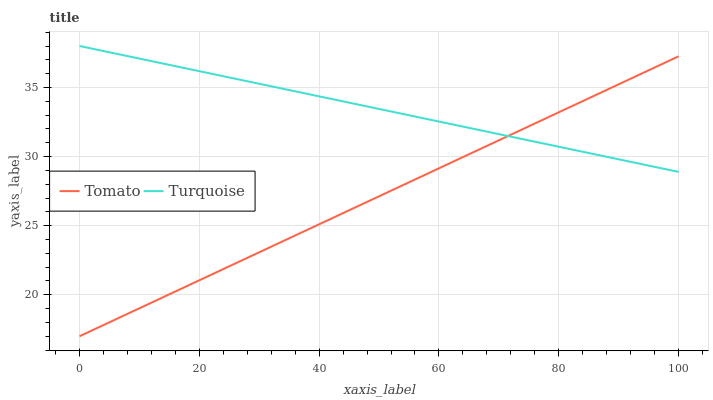Does Tomato have the minimum area under the curve?
Answer yes or no. Yes. Does Turquoise have the maximum area under the curve?
Answer yes or no. Yes. Does Turquoise have the minimum area under the curve?
Answer yes or no. No. Is Tomato the smoothest?
Answer yes or no. Yes. Is Turquoise the roughest?
Answer yes or no. Yes. Is Turquoise the smoothest?
Answer yes or no. No. Does Tomato have the lowest value?
Answer yes or no. Yes. Does Turquoise have the lowest value?
Answer yes or no. No. Does Turquoise have the highest value?
Answer yes or no. Yes. Does Turquoise intersect Tomato?
Answer yes or no. Yes. Is Turquoise less than Tomato?
Answer yes or no. No. Is Turquoise greater than Tomato?
Answer yes or no. No. 